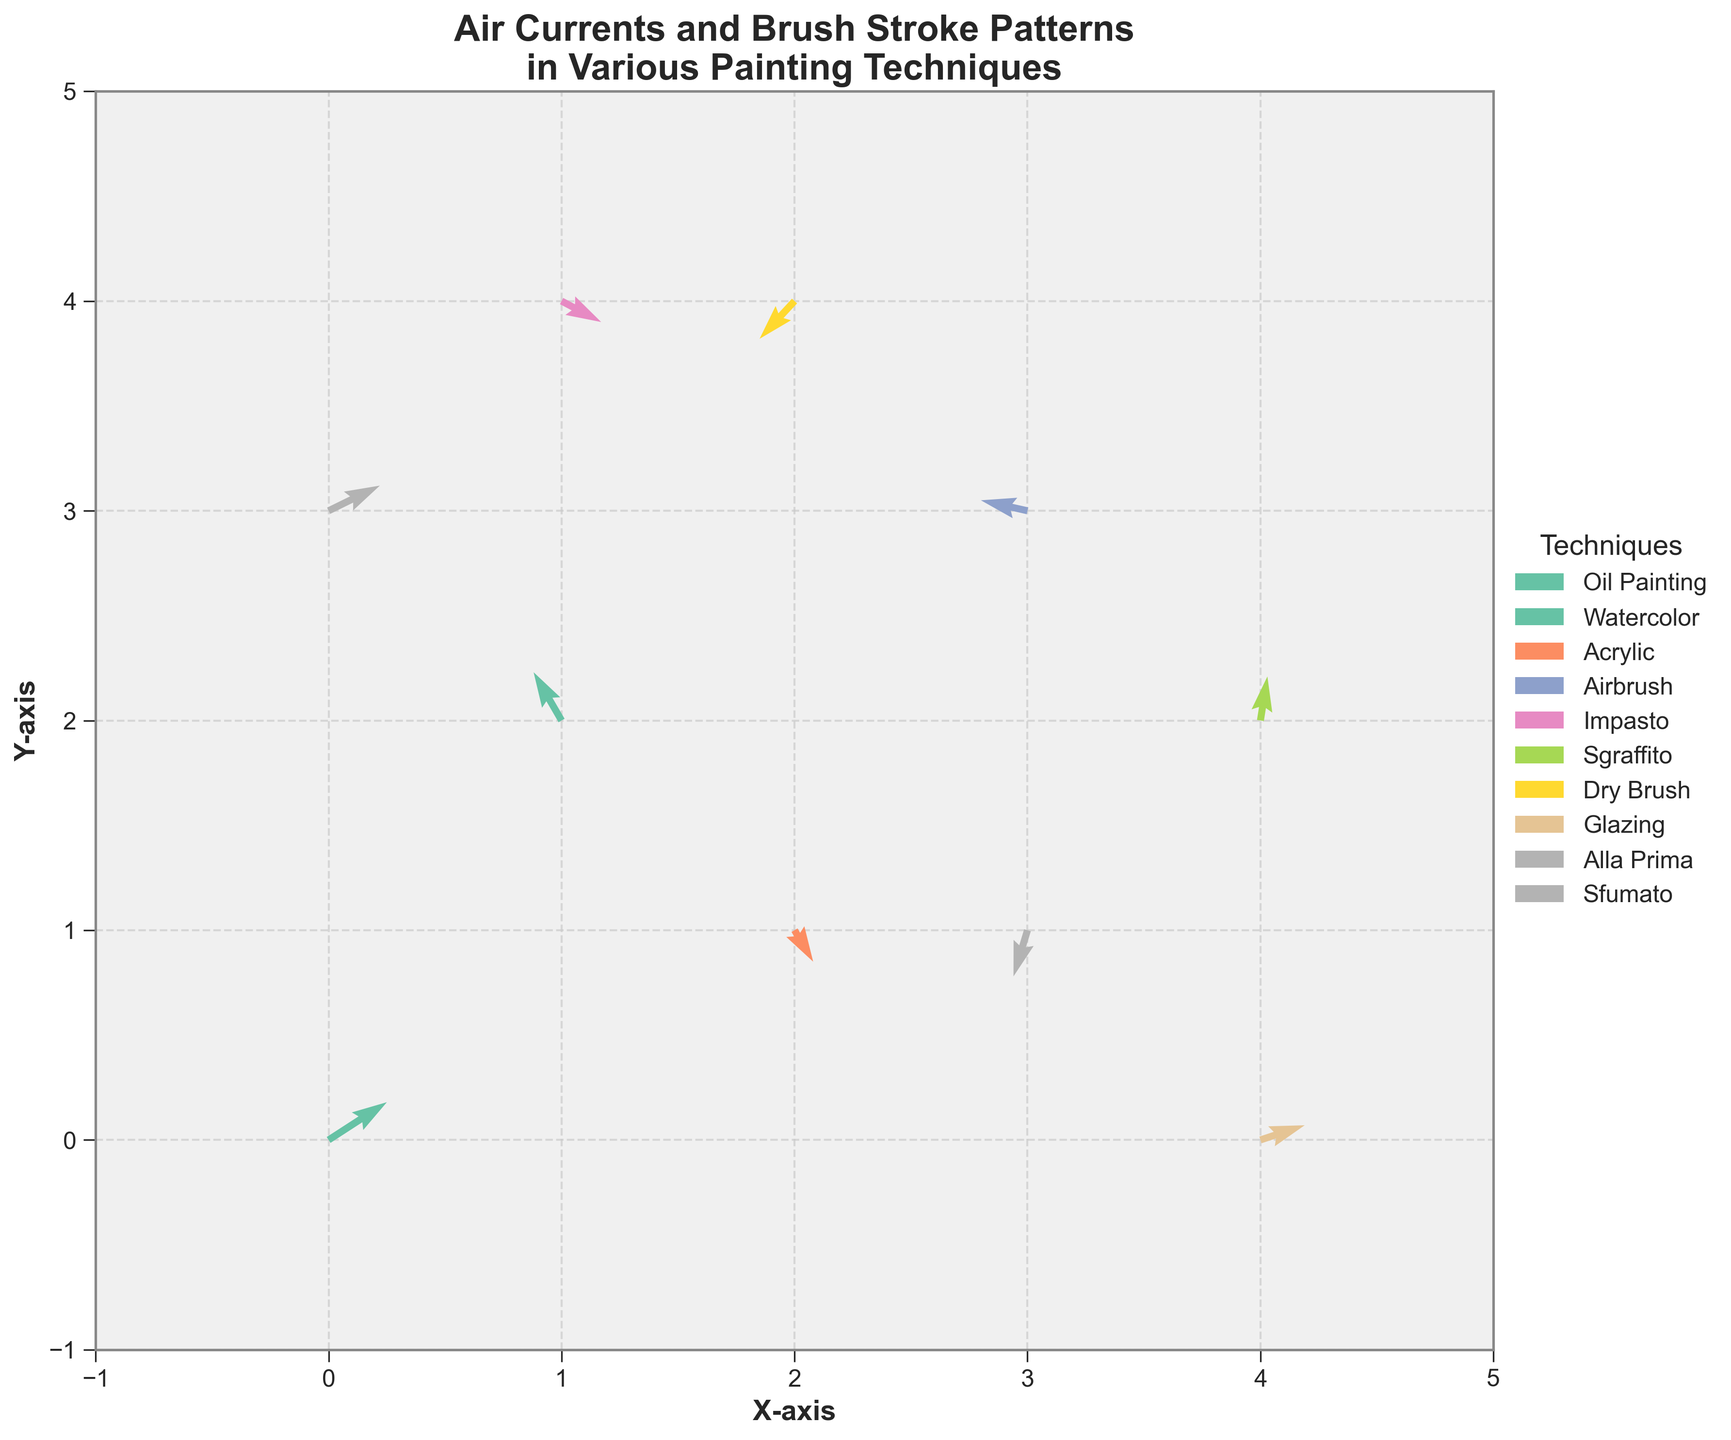What is the title of the figure? The title is found at the top of the figure, indicating what the plot is about.
Answer: Air Currents and Brush Stroke Patterns in Various Painting Techniques How many painting techniques are shown in the plot? Look at the legend, which shows the labels of the different techniques depicted in the plot. Counting these labels will give the number of techniques.
Answer: 9 Which technique has the strongest horizontal vector component? Compare the lengths of the horizontal components (u) of the vectors for each technique. The longest horizontal component indicates the strongest vector. Oil Painting has the vector (2.5, 1.8) where 2.5 is the largest u-value.
Answer: Oil Painting What is the direction of the vector for Sgraffito? Look at the direction of the arrow representing Sgraffito in the plot. The vector is pointed in a way that corresponds to its u and v values. Sgraffito has a vector (0.3, 2.1), so it points slightly right and largely upwards.
Answer: Slightly right and largely upwards Compare the vectors for Acrylic and Alla Prima. Which one has a stronger downward component? Compare the v components of the vectors for both techniques. Acrylic has (0.8, -1.5) and Alla Prima has (-0.6, -2.2). The more negative v indicates a stronger downward component.
Answer: Alla Prima What is the average vertical component of the vectors for Watercolor and Impasto? Find the v components for Watercolor (2.3) and Impasto (-1.0). Calculate the average: (2.3 + (-1.0)) / 2 = 0.65.
Answer: 0.65 Which technique is represented by the vector pointing closest to the left direction? Identify the vectors with the strongest negative u components. Airbrush has a vector of (-2.0, 0.5) which points closest to the left.
Answer: Airbrush How many vectors have a positive vertical component? Count the number of vectors where the v value is positive. positive v-values are: 1.8, 2.3, 2.1, 1.2. There are 4 such vectors.
Answer: 4 What is the range of the y-axis? Look at the y-axis on the left side of the plot to determine the minimum and maximum values displayed.
Answer: -1 to 5 Which technique has the most balanced horizontal and vertical components? Compare the u and v components of each technique to see which ones are closest in magnitude. Sfumato has the components (2.2, 1.2), relatively balanced compared to others.
Answer: Sfumato 